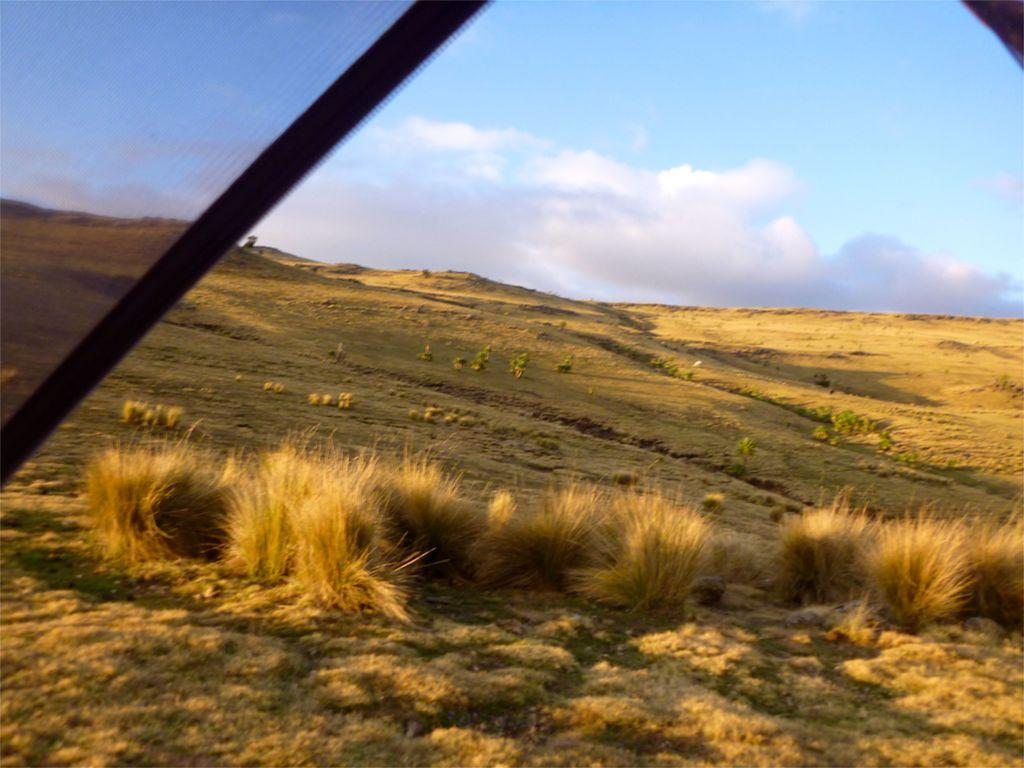What can be seen in the image? There is an object in the image. What else is present on the ground in the image? There are plants on the ground in the image. What is visible in the background of the image? The sky is visible in the background of the image. What can be observed in the sky? There are clouds in the sky. What is the profit of the insect in the image? There is no insect present in the image, so there is no profit to discuss. 